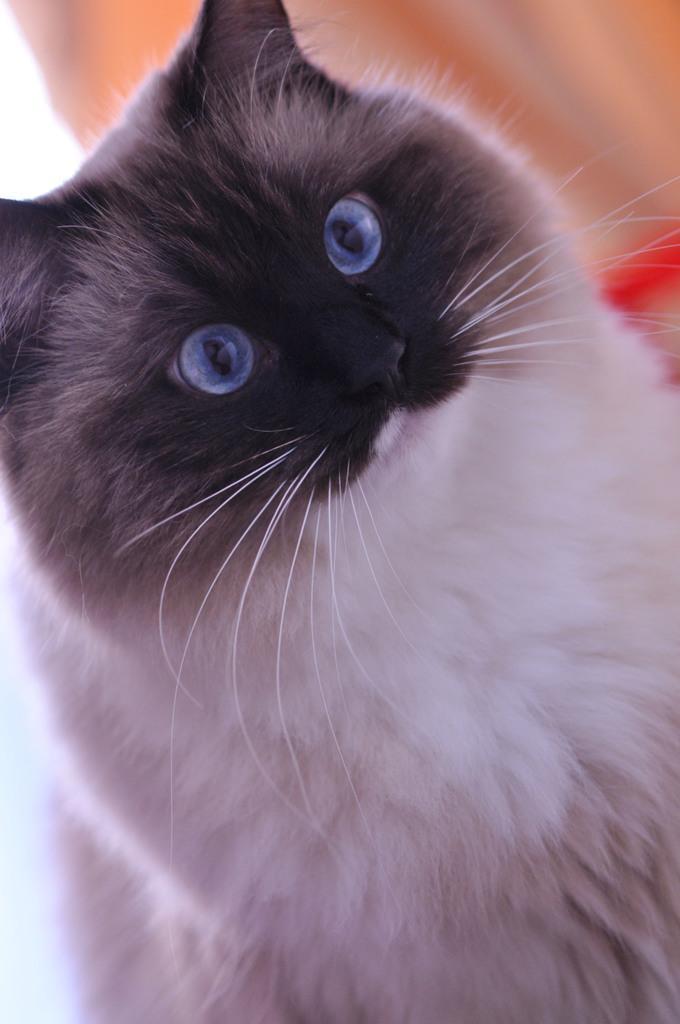How would you summarize this image in a sentence or two? In this picture we can observe a cat which is in black and white color. We can observe purple color eyes. In the background it is completely blur. 